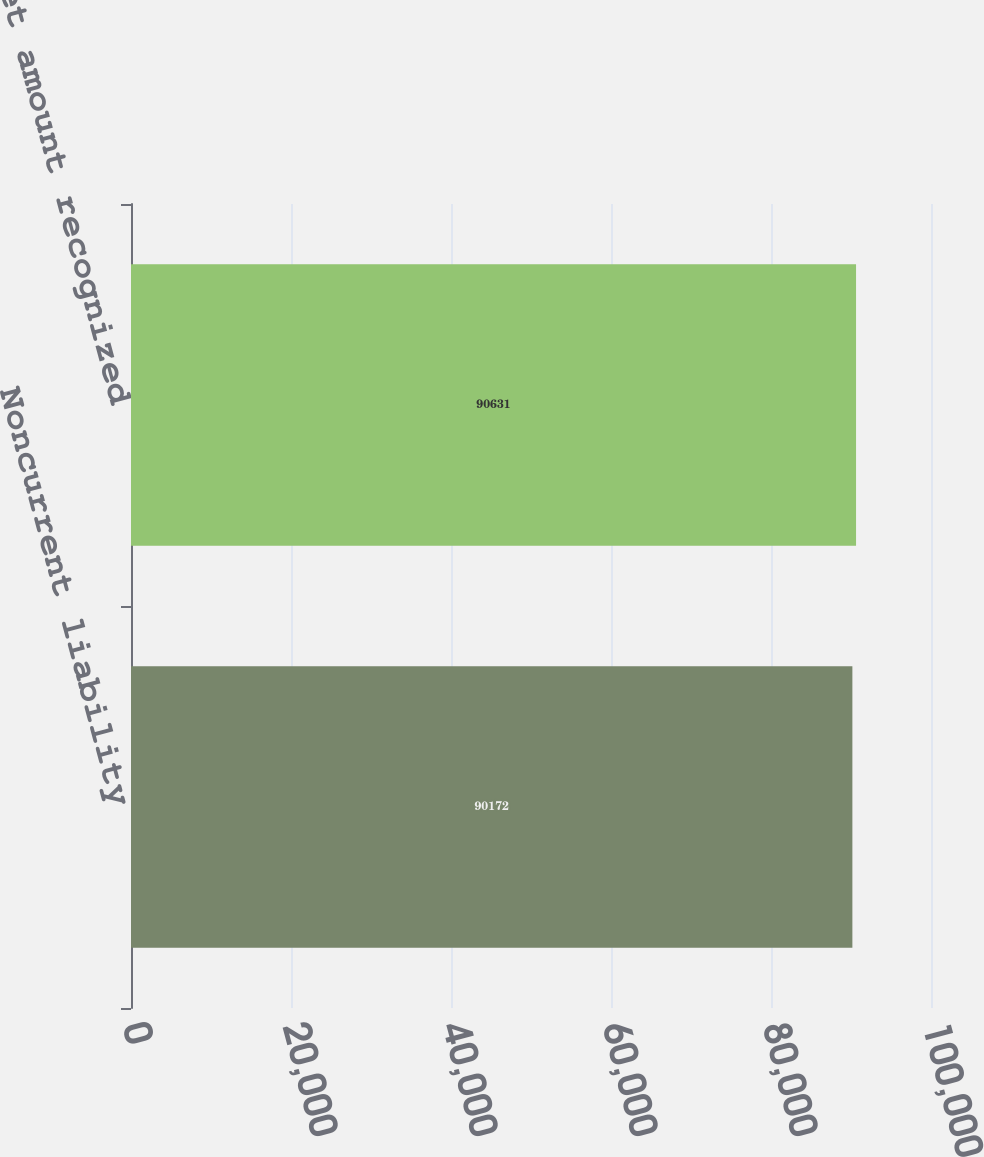Convert chart. <chart><loc_0><loc_0><loc_500><loc_500><bar_chart><fcel>Noncurrent liability<fcel>Net amount recognized<nl><fcel>90172<fcel>90631<nl></chart> 